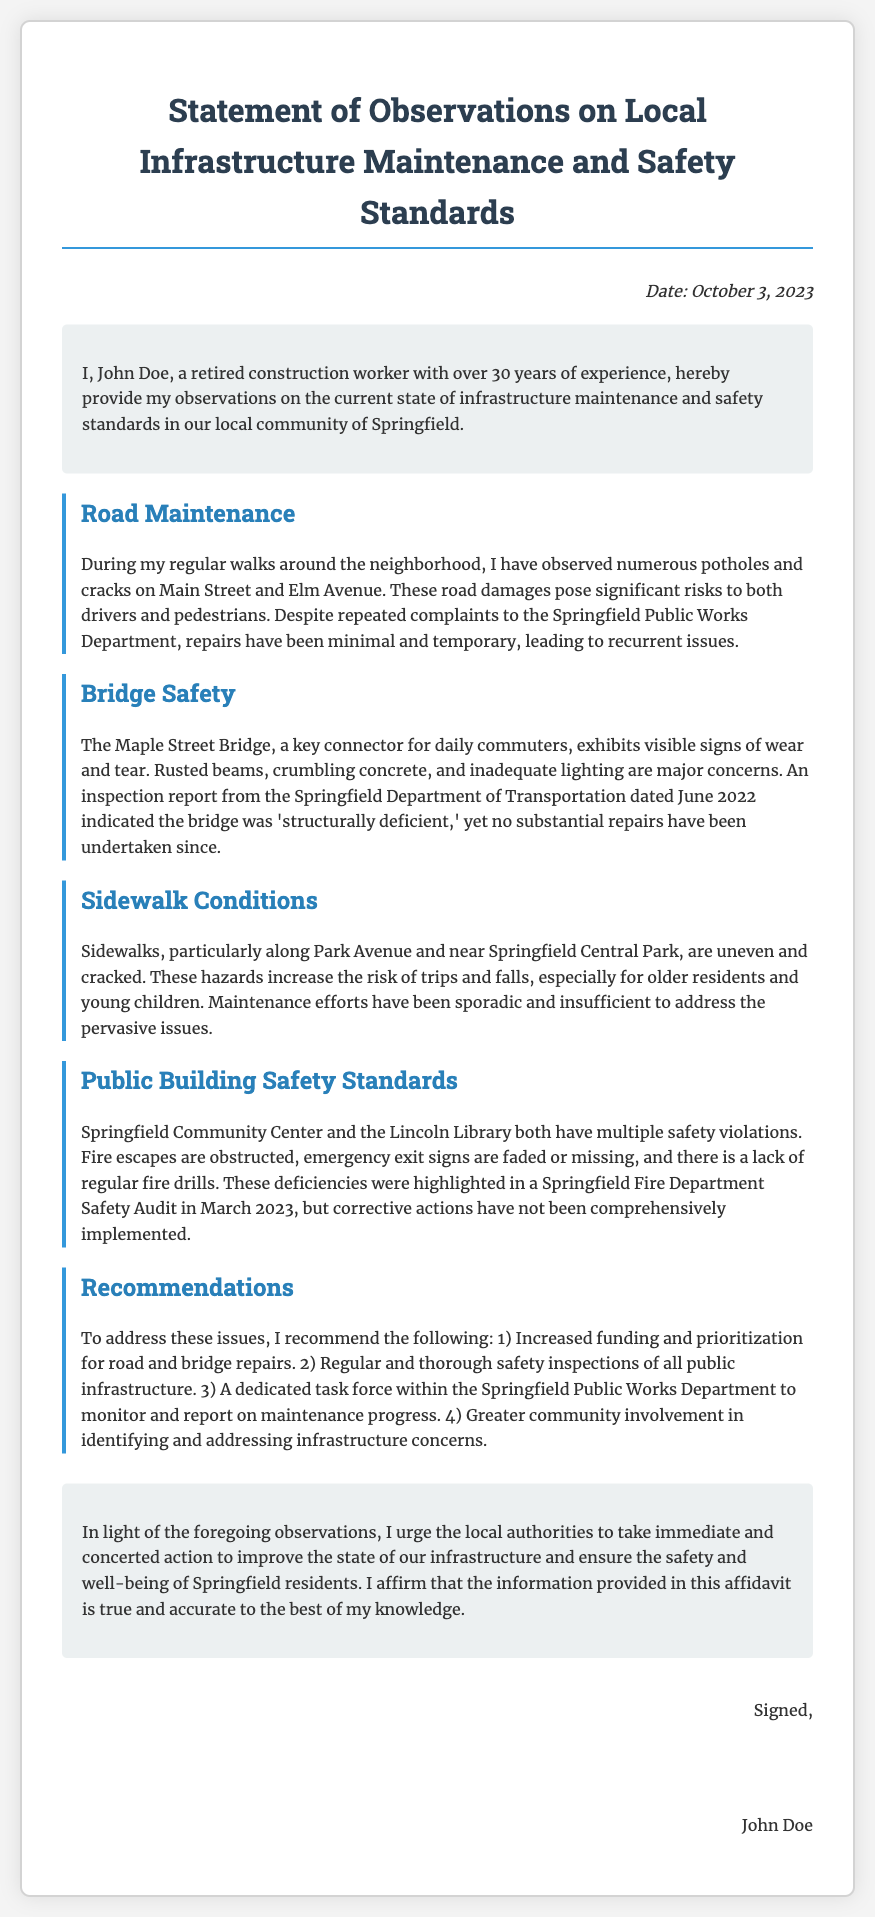What is the date of the affidavit? The date of the affidavit is mentioned at the top right corner of the document.
Answer: October 3, 2023 Who is the author of the affidavit? The author's name is stated in the introduction section of the document.
Answer: John Doe How many years of experience does John Doe have? The experience mentioned in the introduction states the number of years worked in the construction field.
Answer: 30 years What is one major concern regarding the Maple Street Bridge? The concerns for the bridge are detailed in the observation section, focusing on its condition.
Answer: Structurally deficient Which two public buildings have safety violations? The document lists public buildings that have been identified with safety issues.
Answer: Springfield Community Center and Lincoln Library What is one recommended action for improving infrastructure? The recommendations section provides several suggestions for improvement.
Answer: Increased funding and prioritization for road and bridge repairs What is the tone of the author's observations? The overall tone can be inferred from the author's use of language and detailed descriptions throughout the document.
Answer: Urgent How do the observations suggest community involvement? Suggestions for community actions are mentioned in the recommendations section that promotes engagement.
Answer: Greater community involvement in identifying and addressing infrastructure concerns 